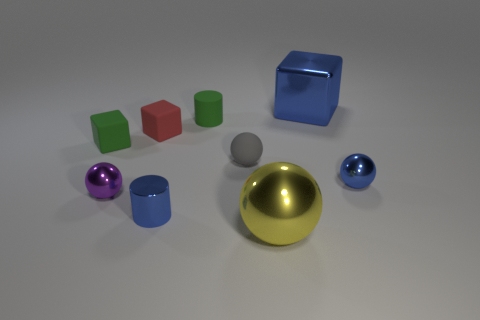Subtract all tiny spheres. How many spheres are left? 1 Add 1 tiny metallic cylinders. How many objects exist? 10 Subtract all blocks. How many objects are left? 6 Subtract all yellow balls. How many balls are left? 3 Subtract all cubes. Subtract all tiny red rubber things. How many objects are left? 5 Add 1 yellow objects. How many yellow objects are left? 2 Add 3 small purple shiny cubes. How many small purple shiny cubes exist? 3 Subtract 1 green cubes. How many objects are left? 8 Subtract 3 cubes. How many cubes are left? 0 Subtract all brown spheres. Subtract all red blocks. How many spheres are left? 4 